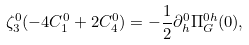<formula> <loc_0><loc_0><loc_500><loc_500>\zeta _ { 3 } ^ { 0 } ( - 4 C _ { 1 } ^ { 0 } + 2 C _ { 4 } ^ { 0 } ) = - \frac { 1 } { 2 } \partial _ { h } ^ { 0 } \Pi _ { G } ^ { 0 h } ( 0 ) ,</formula> 